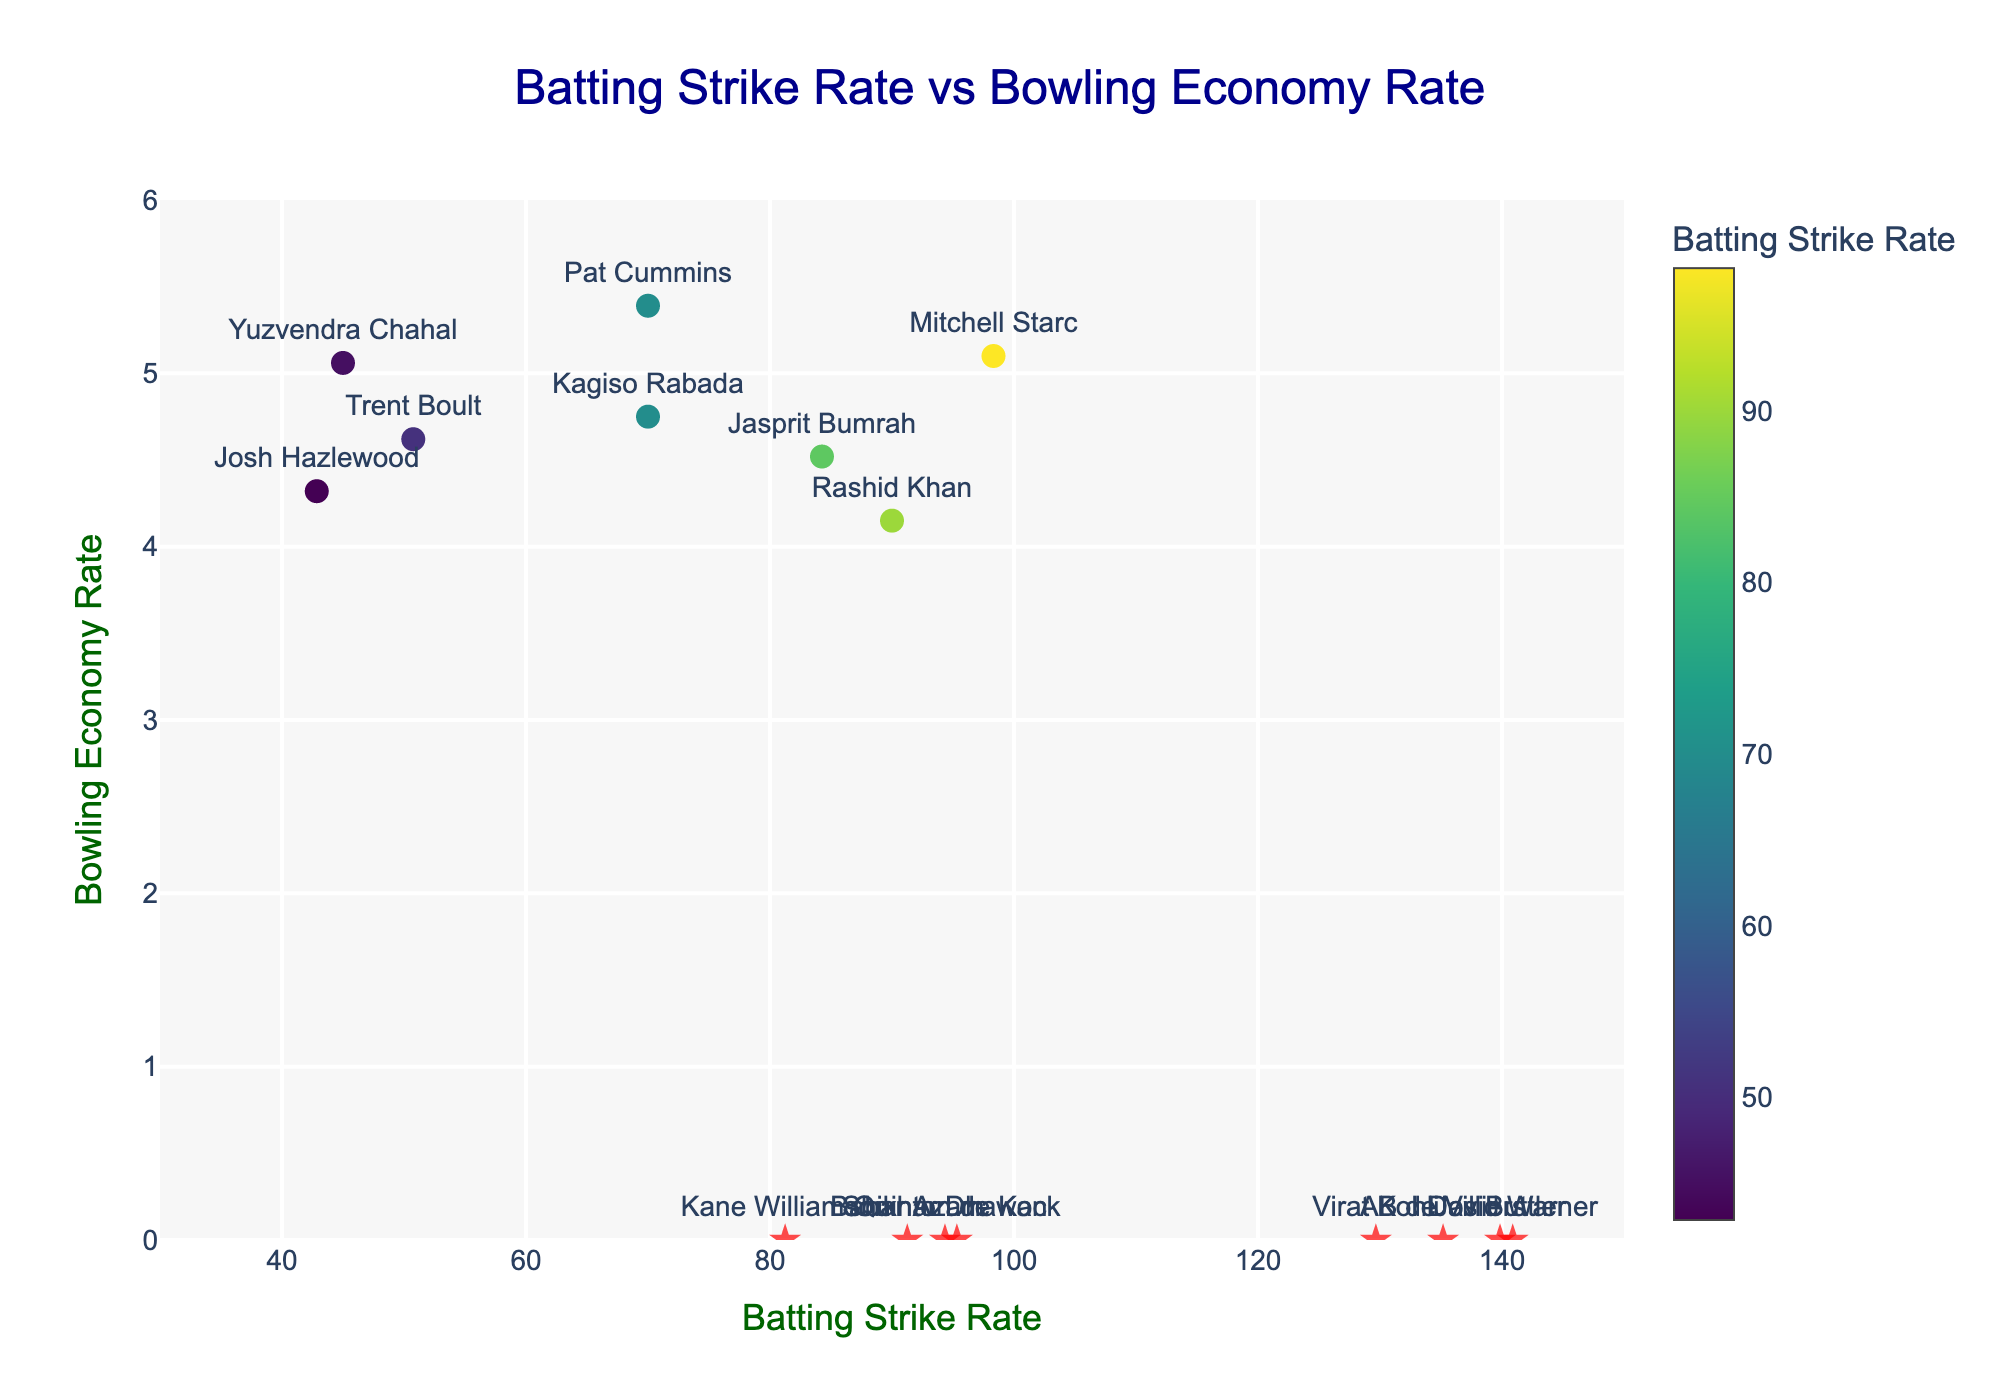What is the title of the figure? The title of the figure is placed at the top center of the plotted graph. It summarizes what the graph is about. It reads 'Batting Strike Rate vs Bowling Economy Rate'.
Answer: Batting Strike Rate vs Bowling Economy Rate What does the x-axis represent? The x-axis, which is the horizontal axis, represents the Batting Strike Rate of the players.
Answer: Batting Strike Rate What does the y-axis represent? The y-axis, which is the vertical axis, represents the Bowling Economy Rate of the players.
Answer: Bowling Economy Rate Which player has the highest Batting Strike Rate? To find the player with the highest Batting Strike Rate, look for the data point with the highest value along the x-axis. David Warner has the highest Batting Strike Rate of 140.88.
Answer: David Warner Which player has the lowest Bowling Economy Rate? To find the player with the lowest Bowling Economy Rate, look for the data point with the lowest value along the y-axis. Rashid Khan has the lowest Bowling Economy Rate of 4.15.
Answer: Rashid Khan How many players have both Batting Strike Rate and Bowling Economy Rate data points? Players with both stats will have points plotted above the x-axis (not at y=0). Count these markers. There are eight such players: Mitchell Starc, Jasprit Bumrah, Rashid Khan, Pat Cummins, Trent Boult, Kagiso Rabada, Yuzvendra Chahal, and Josh Hazlewood.
Answer: 8 Which player has the highest Bowling Economy Rate among those who have both Batting Strike Rate and Bowling Economy Rate data? Look for the highest point among those above the x-axis. Pat Cummins has the highest Bowling Economy Rate of 5.39 among the players with both stats.
Answer: Pat Cummins What is the approximate average Bowling Economy Rate of all players with this data available? Add all the Bowling Economy Rates and divide by the number of players with this data: (5.10 + 4.52 + 4.15 + 5.39 + 4.62 + 4.75 + 5.06 + 4.32) / 8 ≈ 4.614.
Answer: 4.61 Compare the Batting Strike Rate of Virat Kohli and AB de Villiers. Who has a higher rate? Virat Kohli has a Batting Strike Rate of 129.66, while AB de Villiers has 135.17. Since 135.17 > 129.66, AB de Villiers has a higher Batting Strike Rate.
Answer: AB de Villiers Which player has a Batting Strike Rate closest to 100? Look for the player whose Batting Strike Rate is nearest to 100. Mitchell Starc has a Batting Strike Rate of 98.32, which is closest to 100.
Answer: Mitchell Starc 